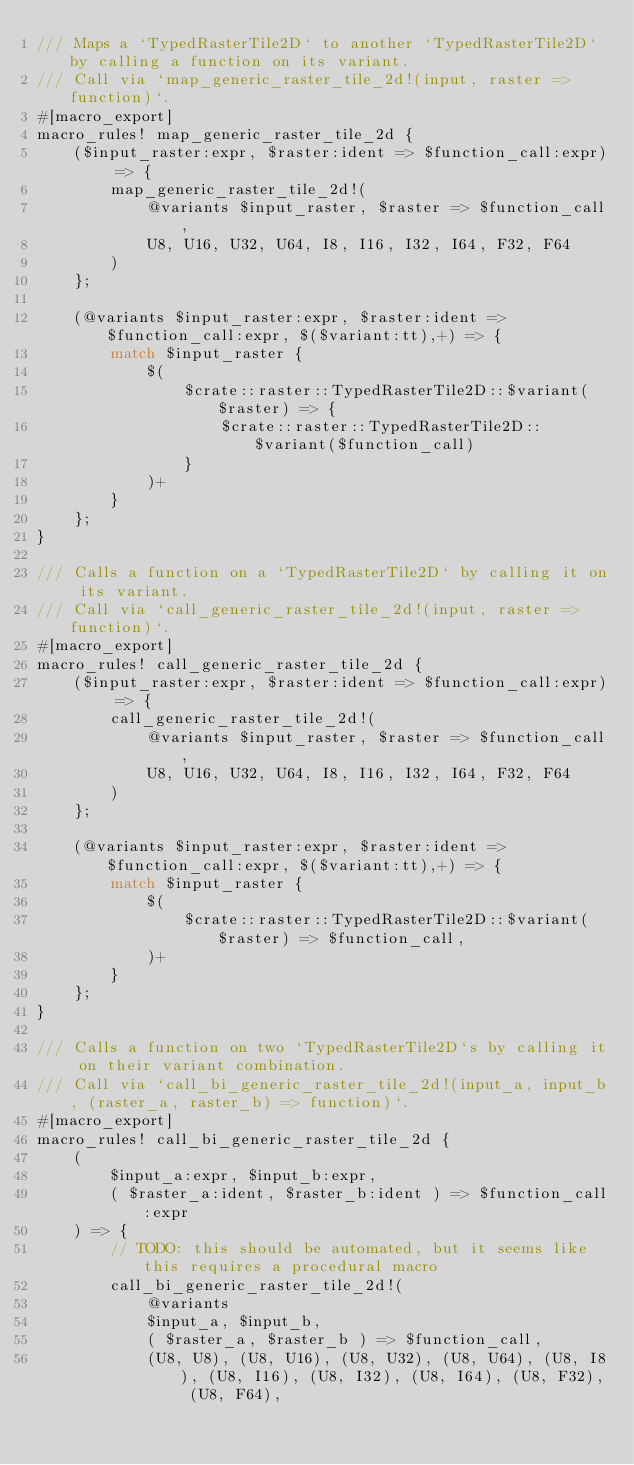Convert code to text. <code><loc_0><loc_0><loc_500><loc_500><_Rust_>/// Maps a `TypedRasterTile2D` to another `TypedRasterTile2D` by calling a function on its variant.
/// Call via `map_generic_raster_tile_2d!(input, raster => function)`.
#[macro_export]
macro_rules! map_generic_raster_tile_2d {
    ($input_raster:expr, $raster:ident => $function_call:expr) => {
        map_generic_raster_tile_2d!(
            @variants $input_raster, $raster => $function_call,
            U8, U16, U32, U64, I8, I16, I32, I64, F32, F64
        )
    };

    (@variants $input_raster:expr, $raster:ident => $function_call:expr, $($variant:tt),+) => {
        match $input_raster {
            $(
                $crate::raster::TypedRasterTile2D::$variant($raster) => {
                    $crate::raster::TypedRasterTile2D::$variant($function_call)
                }
            )+
        }
    };
}

/// Calls a function on a `TypedRasterTile2D` by calling it on its variant.
/// Call via `call_generic_raster_tile_2d!(input, raster => function)`.
#[macro_export]
macro_rules! call_generic_raster_tile_2d {
    ($input_raster:expr, $raster:ident => $function_call:expr) => {
        call_generic_raster_tile_2d!(
            @variants $input_raster, $raster => $function_call,
            U8, U16, U32, U64, I8, I16, I32, I64, F32, F64
        )
    };

    (@variants $input_raster:expr, $raster:ident => $function_call:expr, $($variant:tt),+) => {
        match $input_raster {
            $(
                $crate::raster::TypedRasterTile2D::$variant($raster) => $function_call,
            )+
        }
    };
}

/// Calls a function on two `TypedRasterTile2D`s by calling it on their variant combination.
/// Call via `call_bi_generic_raster_tile_2d!(input_a, input_b, (raster_a, raster_b) => function)`.
#[macro_export]
macro_rules! call_bi_generic_raster_tile_2d {
    (
        $input_a:expr, $input_b:expr,
        ( $raster_a:ident, $raster_b:ident ) => $function_call:expr
    ) => {
        // TODO: this should be automated, but it seems like this requires a procedural macro
        call_bi_generic_raster_tile_2d!(
            @variants
            $input_a, $input_b,
            ( $raster_a, $raster_b ) => $function_call,
            (U8, U8), (U8, U16), (U8, U32), (U8, U64), (U8, I8), (U8, I16), (U8, I32), (U8, I64), (U8, F32), (U8, F64),</code> 